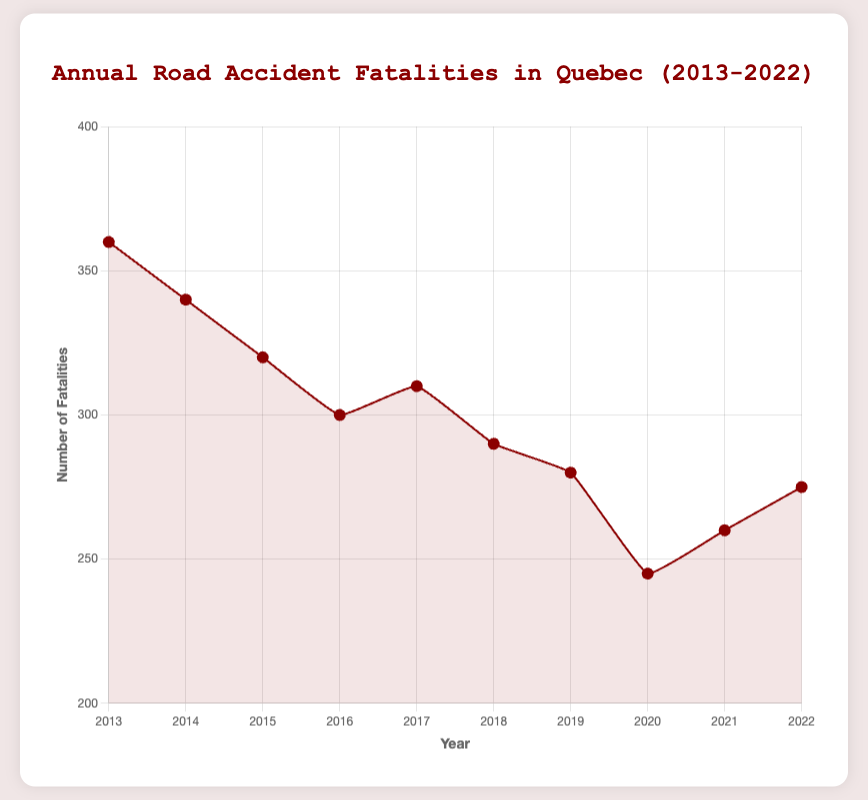What year had the highest number of road accident fatalities? To find the year with the highest number of road accident fatalities, look for the peak value in the plot. The highest number of fatalities is 360, which corresponds to the year 2013.
Answer: 2013 What year experienced the lowest number of fatalities? Identify the lowest point on the plot. The lowest number of fatalities is 245, which occurred in the year 2020.
Answer: 2020 How much did the number of fatalities decrease from 2013 to 2020? Subtract the fatalities in 2020 from the fatalities in 2013: 360 (2013) - 245 (2020) = 115.
Answer: 115 Which year saw an increase in fatalities compared to the previous year? Look for years where the line chart shows an upward slope. Between 2016 and 2017, and between 2020 and 2021, there are increases. Focus on 2017 and 2021.
Answer: 2017, 2021 What is the average number of fatalities over the decade? Add up all the fatalities from each year and divide by the number of years (10). (360 + 340 + 320 + 300 + 310 + 290 + 280 + 245 + 260 + 275) / 10 = 2980 / 10 = 298.
Answer: 298 By how much did the number of fatalities change from 2019 to 2022? Subtract the fatalities in 2019 from the fatalities in 2022: 275 (2022) - 280 (2019) = -5, indicating a decrease.
Answer: -5 In which year was the number of fatalities closest to 300? Look at the plot to find the year where the fatalities are closest to 300. The number of fatalities in 2016 was exactly 300.
Answer: 2016 What is the trend from 2013 to 2019? Observe the overall direction of the line from 2013 to 2019. The trend shows a general decrease in fatalities from 360 in 2013 to 280 in 2019.
Answer: Decreasing How much did the number of fatalities decrease from 2013 to 2016? Subtract the number of fatalities in 2016 from the number in 2013: 360 (2013) - 300 (2016) = 60.
Answer: 60 